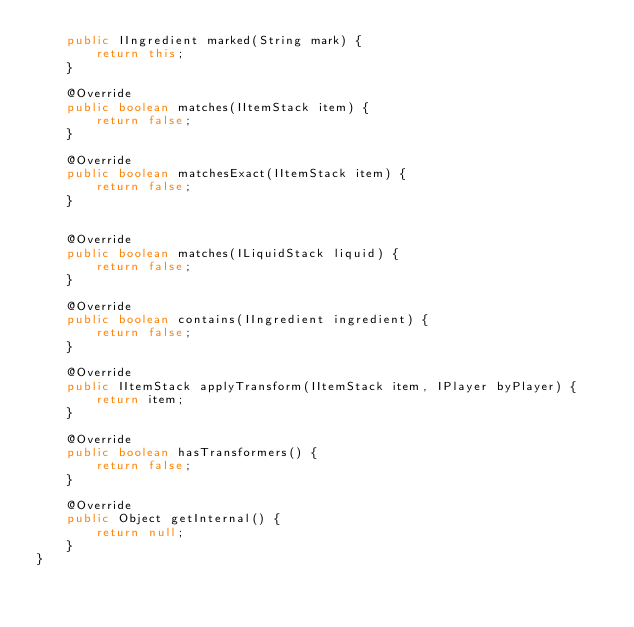<code> <loc_0><loc_0><loc_500><loc_500><_Java_>    public IIngredient marked(String mark) {
        return this;
    }
    
    @Override
    public boolean matches(IItemStack item) {
        return false;
    }
    
    @Override
    public boolean matchesExact(IItemStack item) {
        return false;
    }
    
    
    @Override
    public boolean matches(ILiquidStack liquid) {
        return false;
    }
    
    @Override
    public boolean contains(IIngredient ingredient) {
        return false;
    }
    
    @Override
    public IItemStack applyTransform(IItemStack item, IPlayer byPlayer) {
        return item;
    }
    
    @Override
    public boolean hasTransformers() {
        return false;
    }
    
    @Override
    public Object getInternal() {
        return null;
    }
}
</code> 